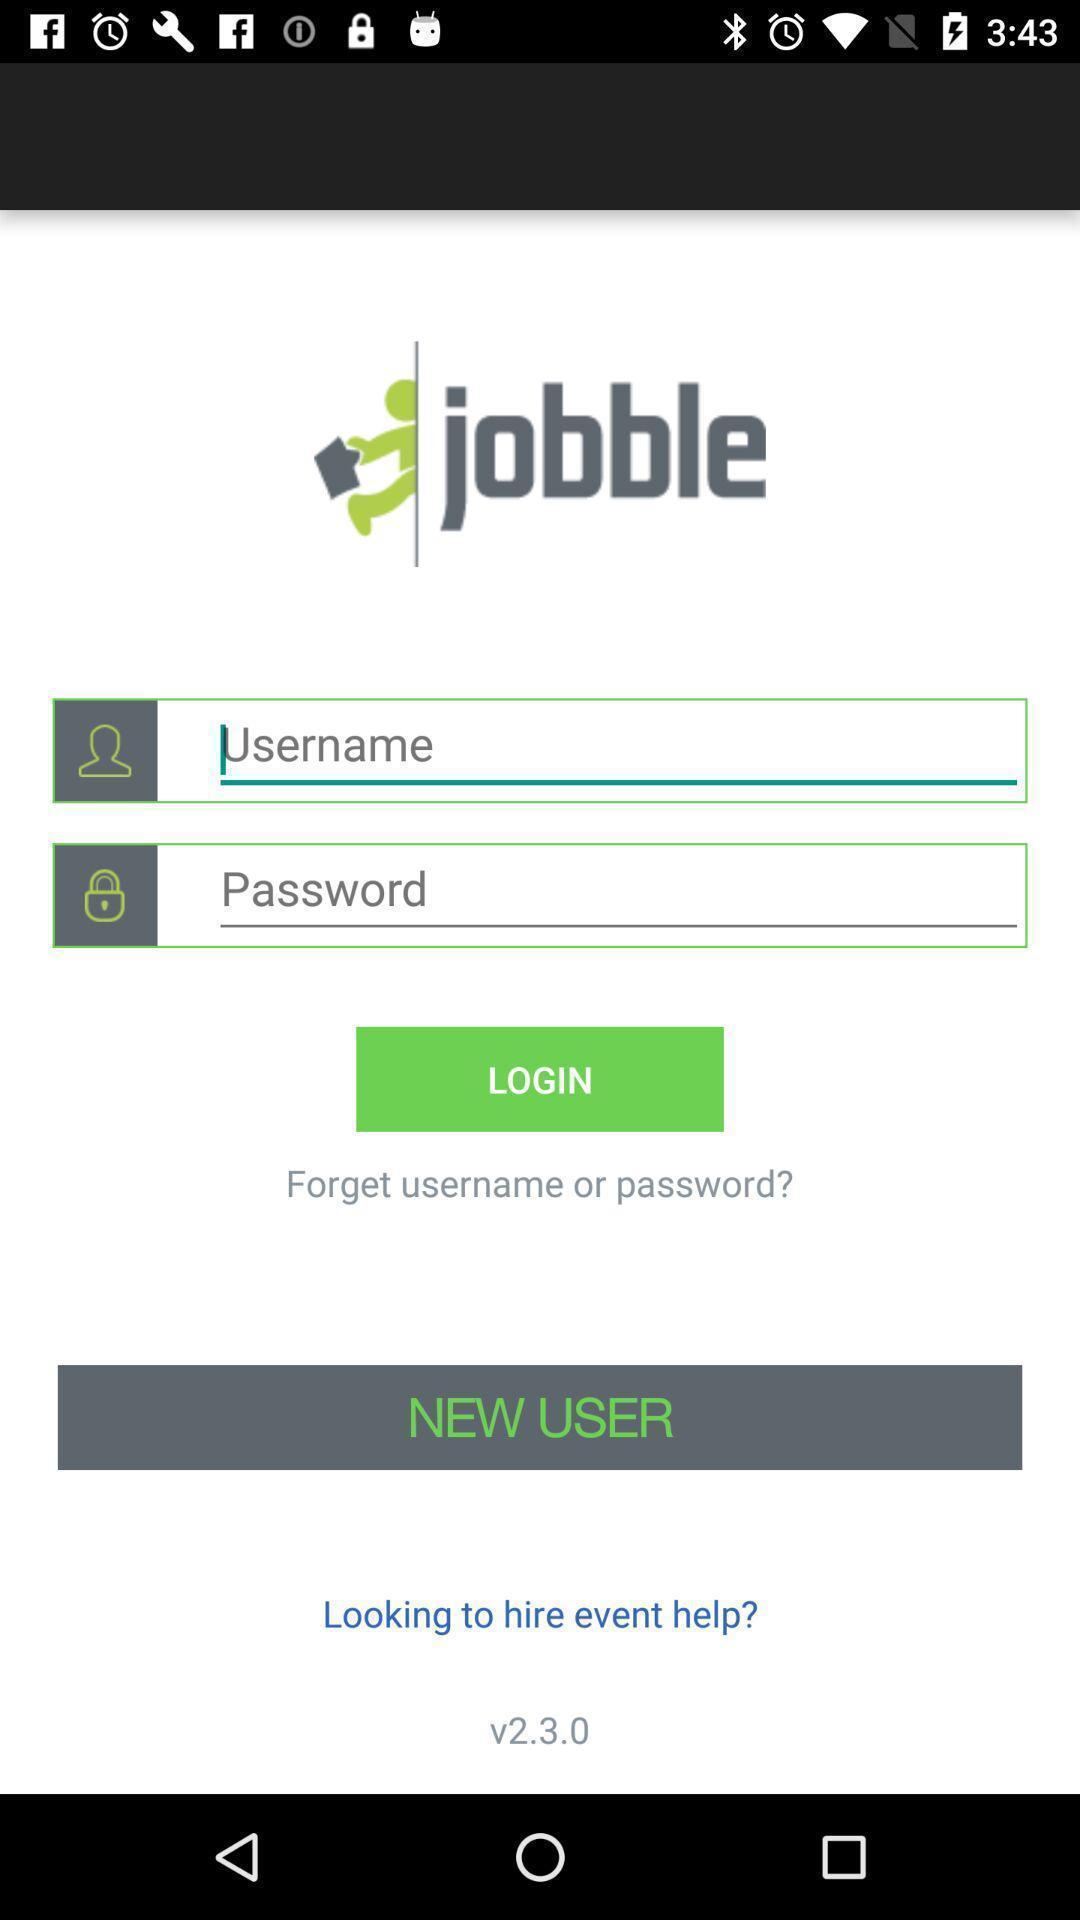Give me a summary of this screen capture. Page displaying log in option. 